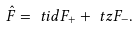Convert formula to latex. <formula><loc_0><loc_0><loc_500><loc_500>\hat { F } & = \ t i d F _ { + } + \ t z F _ { - } .</formula> 